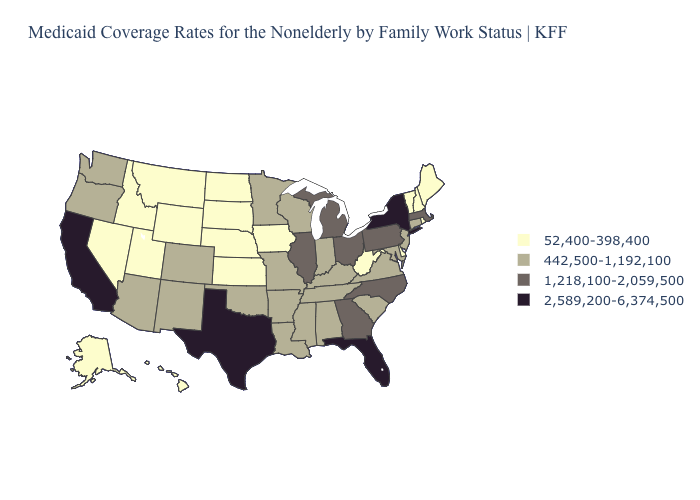Does the map have missing data?
Quick response, please. No. What is the value of Maine?
Be succinct. 52,400-398,400. Name the states that have a value in the range 1,218,100-2,059,500?
Be succinct. Georgia, Illinois, Massachusetts, Michigan, North Carolina, Ohio, Pennsylvania. Does Virginia have a higher value than Hawaii?
Give a very brief answer. Yes. Which states have the highest value in the USA?
Concise answer only. California, Florida, New York, Texas. Which states hav the highest value in the South?
Answer briefly. Florida, Texas. What is the value of Massachusetts?
Answer briefly. 1,218,100-2,059,500. Name the states that have a value in the range 52,400-398,400?
Write a very short answer. Alaska, Delaware, Hawaii, Idaho, Iowa, Kansas, Maine, Montana, Nebraska, Nevada, New Hampshire, North Dakota, Rhode Island, South Dakota, Utah, Vermont, West Virginia, Wyoming. Which states hav the highest value in the MidWest?
Concise answer only. Illinois, Michigan, Ohio. Name the states that have a value in the range 1,218,100-2,059,500?
Be succinct. Georgia, Illinois, Massachusetts, Michigan, North Carolina, Ohio, Pennsylvania. What is the value of North Dakota?
Be succinct. 52,400-398,400. Does the first symbol in the legend represent the smallest category?
Be succinct. Yes. What is the highest value in the USA?
Keep it brief. 2,589,200-6,374,500. What is the value of Idaho?
Give a very brief answer. 52,400-398,400. 